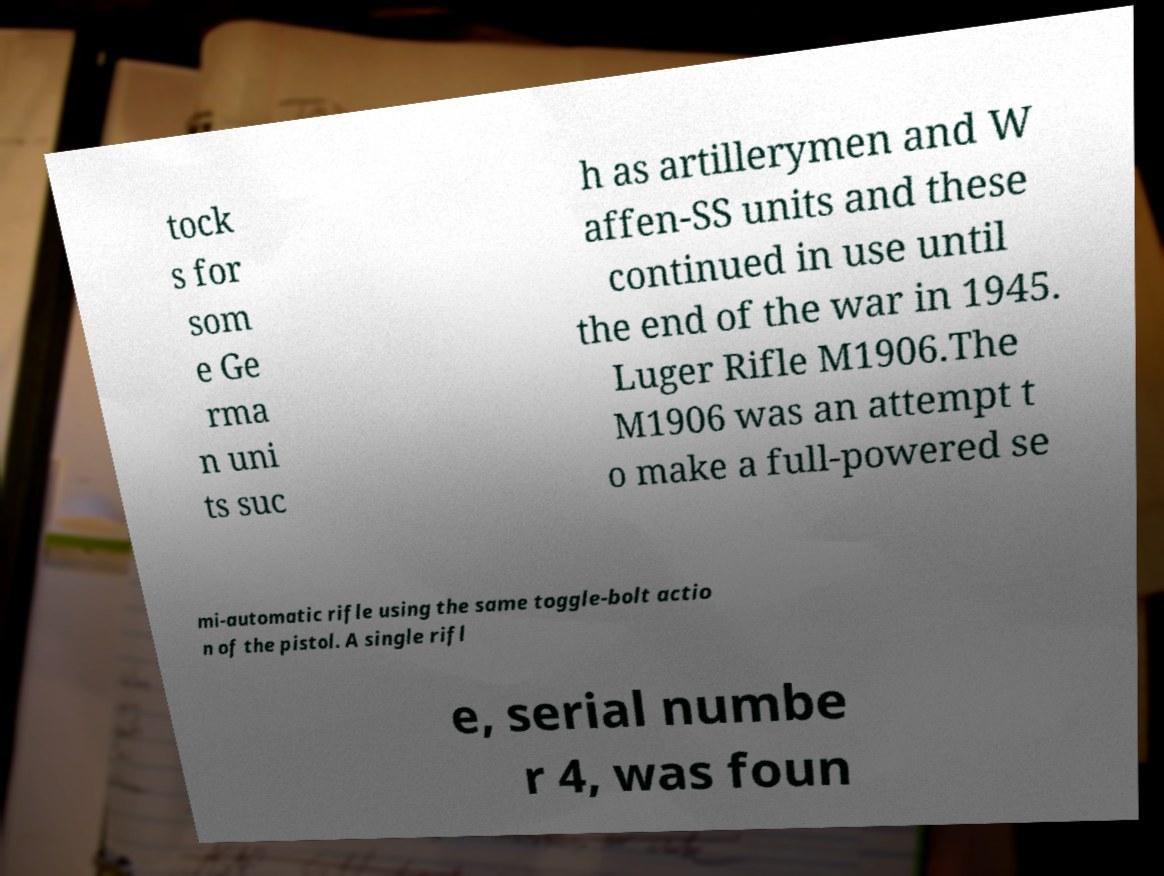Could you assist in decoding the text presented in this image and type it out clearly? tock s for som e Ge rma n uni ts suc h as artillerymen and W affen-SS units and these continued in use until the end of the war in 1945. Luger Rifle M1906.The M1906 was an attempt t o make a full-powered se mi-automatic rifle using the same toggle-bolt actio n of the pistol. A single rifl e, serial numbe r 4, was foun 